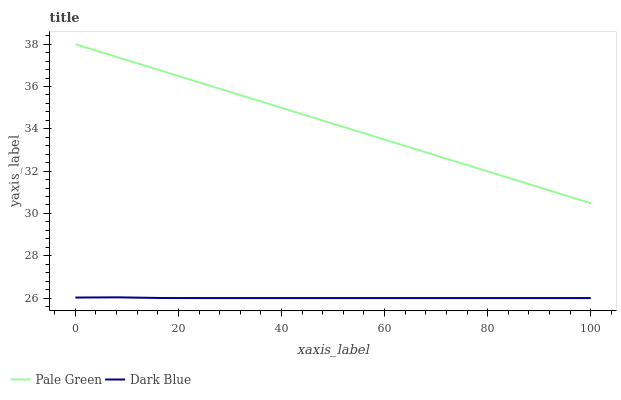Does Dark Blue have the minimum area under the curve?
Answer yes or no. Yes. Does Pale Green have the maximum area under the curve?
Answer yes or no. Yes. Does Pale Green have the minimum area under the curve?
Answer yes or no. No. Is Pale Green the smoothest?
Answer yes or no. Yes. Is Dark Blue the roughest?
Answer yes or no. Yes. Is Pale Green the roughest?
Answer yes or no. No. Does Dark Blue have the lowest value?
Answer yes or no. Yes. Does Pale Green have the lowest value?
Answer yes or no. No. Does Pale Green have the highest value?
Answer yes or no. Yes. Is Dark Blue less than Pale Green?
Answer yes or no. Yes. Is Pale Green greater than Dark Blue?
Answer yes or no. Yes. Does Dark Blue intersect Pale Green?
Answer yes or no. No. 